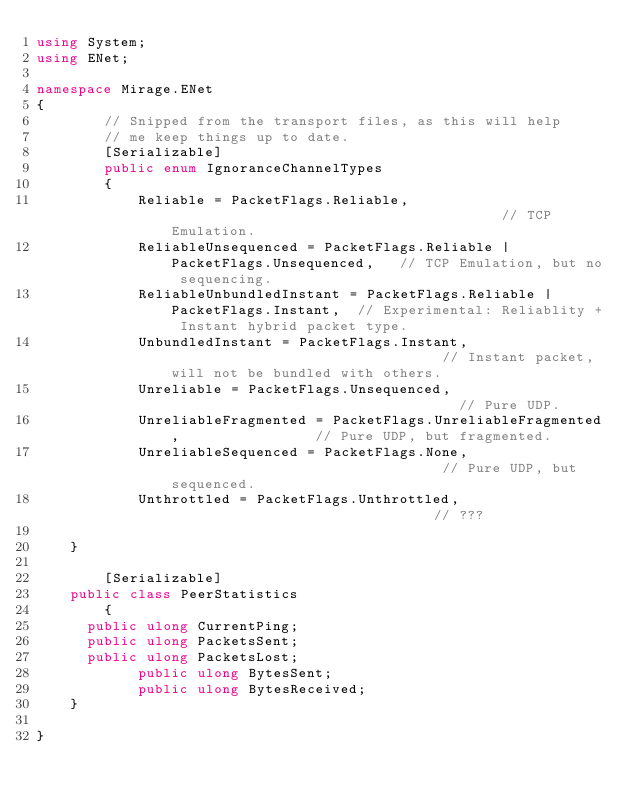<code> <loc_0><loc_0><loc_500><loc_500><_C#_>using System;
using ENet;

namespace Mirage.ENet
{
        // Snipped from the transport files, as this will help
        // me keep things up to date.
        [Serializable]
        public enum IgnoranceChannelTypes
        {
            Reliable = PacketFlags.Reliable,                                        // TCP Emulation.
            ReliableUnsequenced = PacketFlags.Reliable | PacketFlags.Unsequenced,   // TCP Emulation, but no sequencing.
            ReliableUnbundledInstant = PacketFlags.Reliable | PacketFlags.Instant,  // Experimental: Reliablity + Instant hybrid packet type.
            UnbundledInstant = PacketFlags.Instant,                                 // Instant packet, will not be bundled with others.
            Unreliable = PacketFlags.Unsequenced,                                   // Pure UDP.
            UnreliableFragmented = PacketFlags.UnreliableFragmented,                // Pure UDP, but fragmented.
            UnreliableSequenced = PacketFlags.None,                                 // Pure UDP, but sequenced.
            Unthrottled = PacketFlags.Unthrottled,                                // ???

    }

        [Serializable]
		public class PeerStatistics
        {
			public ulong CurrentPing;
			public ulong PacketsSent;
			public ulong PacketsLost;
            public ulong BytesSent;
            public ulong BytesReceived;
		}
		
}
</code> 